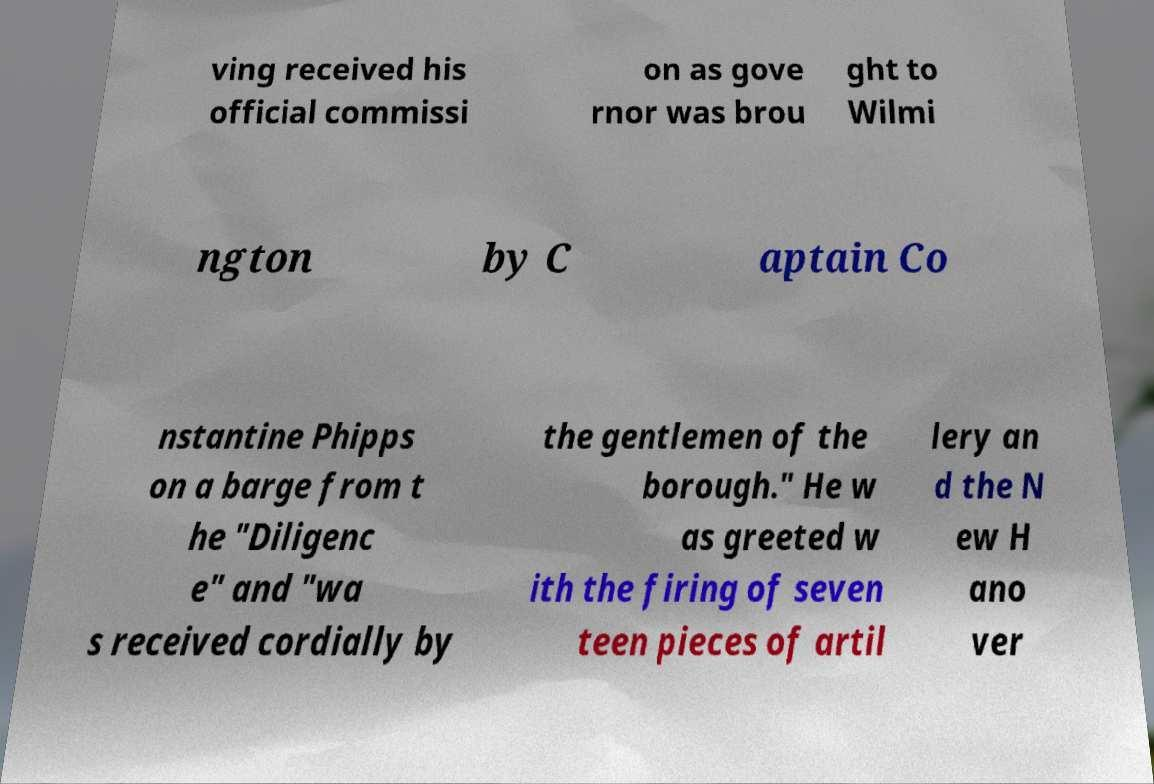There's text embedded in this image that I need extracted. Can you transcribe it verbatim? ving received his official commissi on as gove rnor was brou ght to Wilmi ngton by C aptain Co nstantine Phipps on a barge from t he "Diligenc e" and "wa s received cordially by the gentlemen of the borough." He w as greeted w ith the firing of seven teen pieces of artil lery an d the N ew H ano ver 